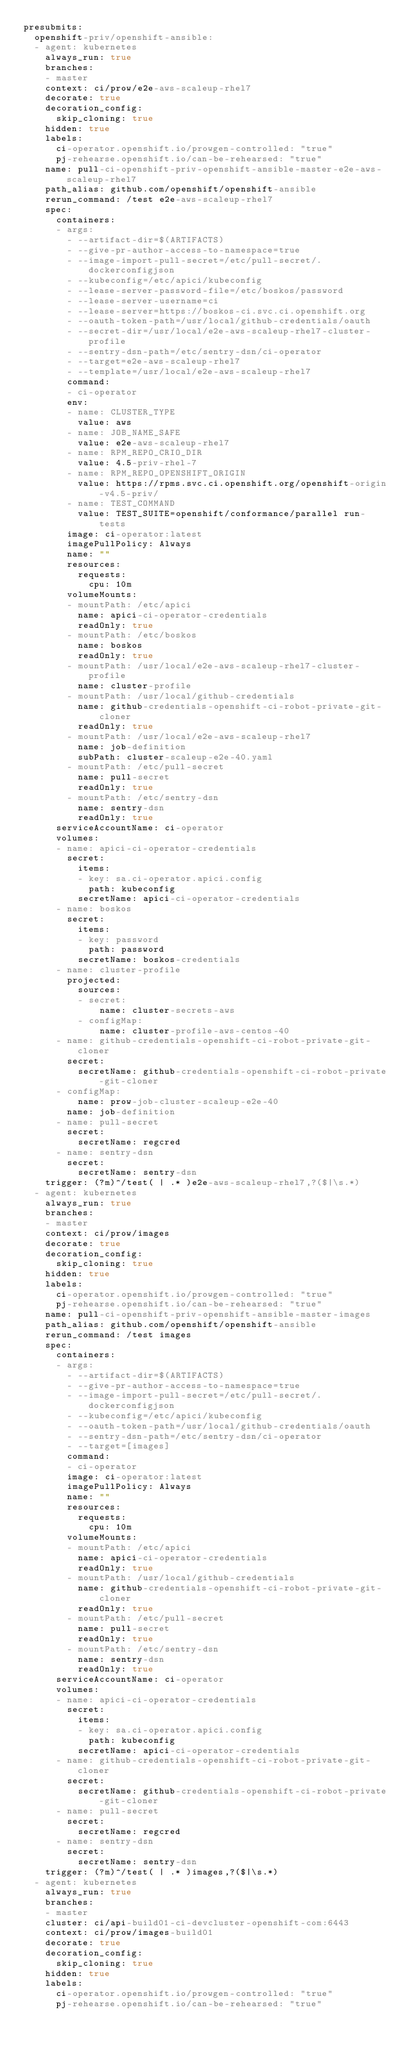Convert code to text. <code><loc_0><loc_0><loc_500><loc_500><_YAML_>presubmits:
  openshift-priv/openshift-ansible:
  - agent: kubernetes
    always_run: true
    branches:
    - master
    context: ci/prow/e2e-aws-scaleup-rhel7
    decorate: true
    decoration_config:
      skip_cloning: true
    hidden: true
    labels:
      ci-operator.openshift.io/prowgen-controlled: "true"
      pj-rehearse.openshift.io/can-be-rehearsed: "true"
    name: pull-ci-openshift-priv-openshift-ansible-master-e2e-aws-scaleup-rhel7
    path_alias: github.com/openshift/openshift-ansible
    rerun_command: /test e2e-aws-scaleup-rhel7
    spec:
      containers:
      - args:
        - --artifact-dir=$(ARTIFACTS)
        - --give-pr-author-access-to-namespace=true
        - --image-import-pull-secret=/etc/pull-secret/.dockerconfigjson
        - --kubeconfig=/etc/apici/kubeconfig
        - --lease-server-password-file=/etc/boskos/password
        - --lease-server-username=ci
        - --lease-server=https://boskos-ci.svc.ci.openshift.org
        - --oauth-token-path=/usr/local/github-credentials/oauth
        - --secret-dir=/usr/local/e2e-aws-scaleup-rhel7-cluster-profile
        - --sentry-dsn-path=/etc/sentry-dsn/ci-operator
        - --target=e2e-aws-scaleup-rhel7
        - --template=/usr/local/e2e-aws-scaleup-rhel7
        command:
        - ci-operator
        env:
        - name: CLUSTER_TYPE
          value: aws
        - name: JOB_NAME_SAFE
          value: e2e-aws-scaleup-rhel7
        - name: RPM_REPO_CRIO_DIR
          value: 4.5-priv-rhel-7
        - name: RPM_REPO_OPENSHIFT_ORIGIN
          value: https://rpms.svc.ci.openshift.org/openshift-origin-v4.5-priv/
        - name: TEST_COMMAND
          value: TEST_SUITE=openshift/conformance/parallel run-tests
        image: ci-operator:latest
        imagePullPolicy: Always
        name: ""
        resources:
          requests:
            cpu: 10m
        volumeMounts:
        - mountPath: /etc/apici
          name: apici-ci-operator-credentials
          readOnly: true
        - mountPath: /etc/boskos
          name: boskos
          readOnly: true
        - mountPath: /usr/local/e2e-aws-scaleup-rhel7-cluster-profile
          name: cluster-profile
        - mountPath: /usr/local/github-credentials
          name: github-credentials-openshift-ci-robot-private-git-cloner
          readOnly: true
        - mountPath: /usr/local/e2e-aws-scaleup-rhel7
          name: job-definition
          subPath: cluster-scaleup-e2e-40.yaml
        - mountPath: /etc/pull-secret
          name: pull-secret
          readOnly: true
        - mountPath: /etc/sentry-dsn
          name: sentry-dsn
          readOnly: true
      serviceAccountName: ci-operator
      volumes:
      - name: apici-ci-operator-credentials
        secret:
          items:
          - key: sa.ci-operator.apici.config
            path: kubeconfig
          secretName: apici-ci-operator-credentials
      - name: boskos
        secret:
          items:
          - key: password
            path: password
          secretName: boskos-credentials
      - name: cluster-profile
        projected:
          sources:
          - secret:
              name: cluster-secrets-aws
          - configMap:
              name: cluster-profile-aws-centos-40
      - name: github-credentials-openshift-ci-robot-private-git-cloner
        secret:
          secretName: github-credentials-openshift-ci-robot-private-git-cloner
      - configMap:
          name: prow-job-cluster-scaleup-e2e-40
        name: job-definition
      - name: pull-secret
        secret:
          secretName: regcred
      - name: sentry-dsn
        secret:
          secretName: sentry-dsn
    trigger: (?m)^/test( | .* )e2e-aws-scaleup-rhel7,?($|\s.*)
  - agent: kubernetes
    always_run: true
    branches:
    - master
    context: ci/prow/images
    decorate: true
    decoration_config:
      skip_cloning: true
    hidden: true
    labels:
      ci-operator.openshift.io/prowgen-controlled: "true"
      pj-rehearse.openshift.io/can-be-rehearsed: "true"
    name: pull-ci-openshift-priv-openshift-ansible-master-images
    path_alias: github.com/openshift/openshift-ansible
    rerun_command: /test images
    spec:
      containers:
      - args:
        - --artifact-dir=$(ARTIFACTS)
        - --give-pr-author-access-to-namespace=true
        - --image-import-pull-secret=/etc/pull-secret/.dockerconfigjson
        - --kubeconfig=/etc/apici/kubeconfig
        - --oauth-token-path=/usr/local/github-credentials/oauth
        - --sentry-dsn-path=/etc/sentry-dsn/ci-operator
        - --target=[images]
        command:
        - ci-operator
        image: ci-operator:latest
        imagePullPolicy: Always
        name: ""
        resources:
          requests:
            cpu: 10m
        volumeMounts:
        - mountPath: /etc/apici
          name: apici-ci-operator-credentials
          readOnly: true
        - mountPath: /usr/local/github-credentials
          name: github-credentials-openshift-ci-robot-private-git-cloner
          readOnly: true
        - mountPath: /etc/pull-secret
          name: pull-secret
          readOnly: true
        - mountPath: /etc/sentry-dsn
          name: sentry-dsn
          readOnly: true
      serviceAccountName: ci-operator
      volumes:
      - name: apici-ci-operator-credentials
        secret:
          items:
          - key: sa.ci-operator.apici.config
            path: kubeconfig
          secretName: apici-ci-operator-credentials
      - name: github-credentials-openshift-ci-robot-private-git-cloner
        secret:
          secretName: github-credentials-openshift-ci-robot-private-git-cloner
      - name: pull-secret
        secret:
          secretName: regcred
      - name: sentry-dsn
        secret:
          secretName: sentry-dsn
    trigger: (?m)^/test( | .* )images,?($|\s.*)
  - agent: kubernetes
    always_run: true
    branches:
    - master
    cluster: ci/api-build01-ci-devcluster-openshift-com:6443
    context: ci/prow/images-build01
    decorate: true
    decoration_config:
      skip_cloning: true
    hidden: true
    labels:
      ci-operator.openshift.io/prowgen-controlled: "true"
      pj-rehearse.openshift.io/can-be-rehearsed: "true"</code> 